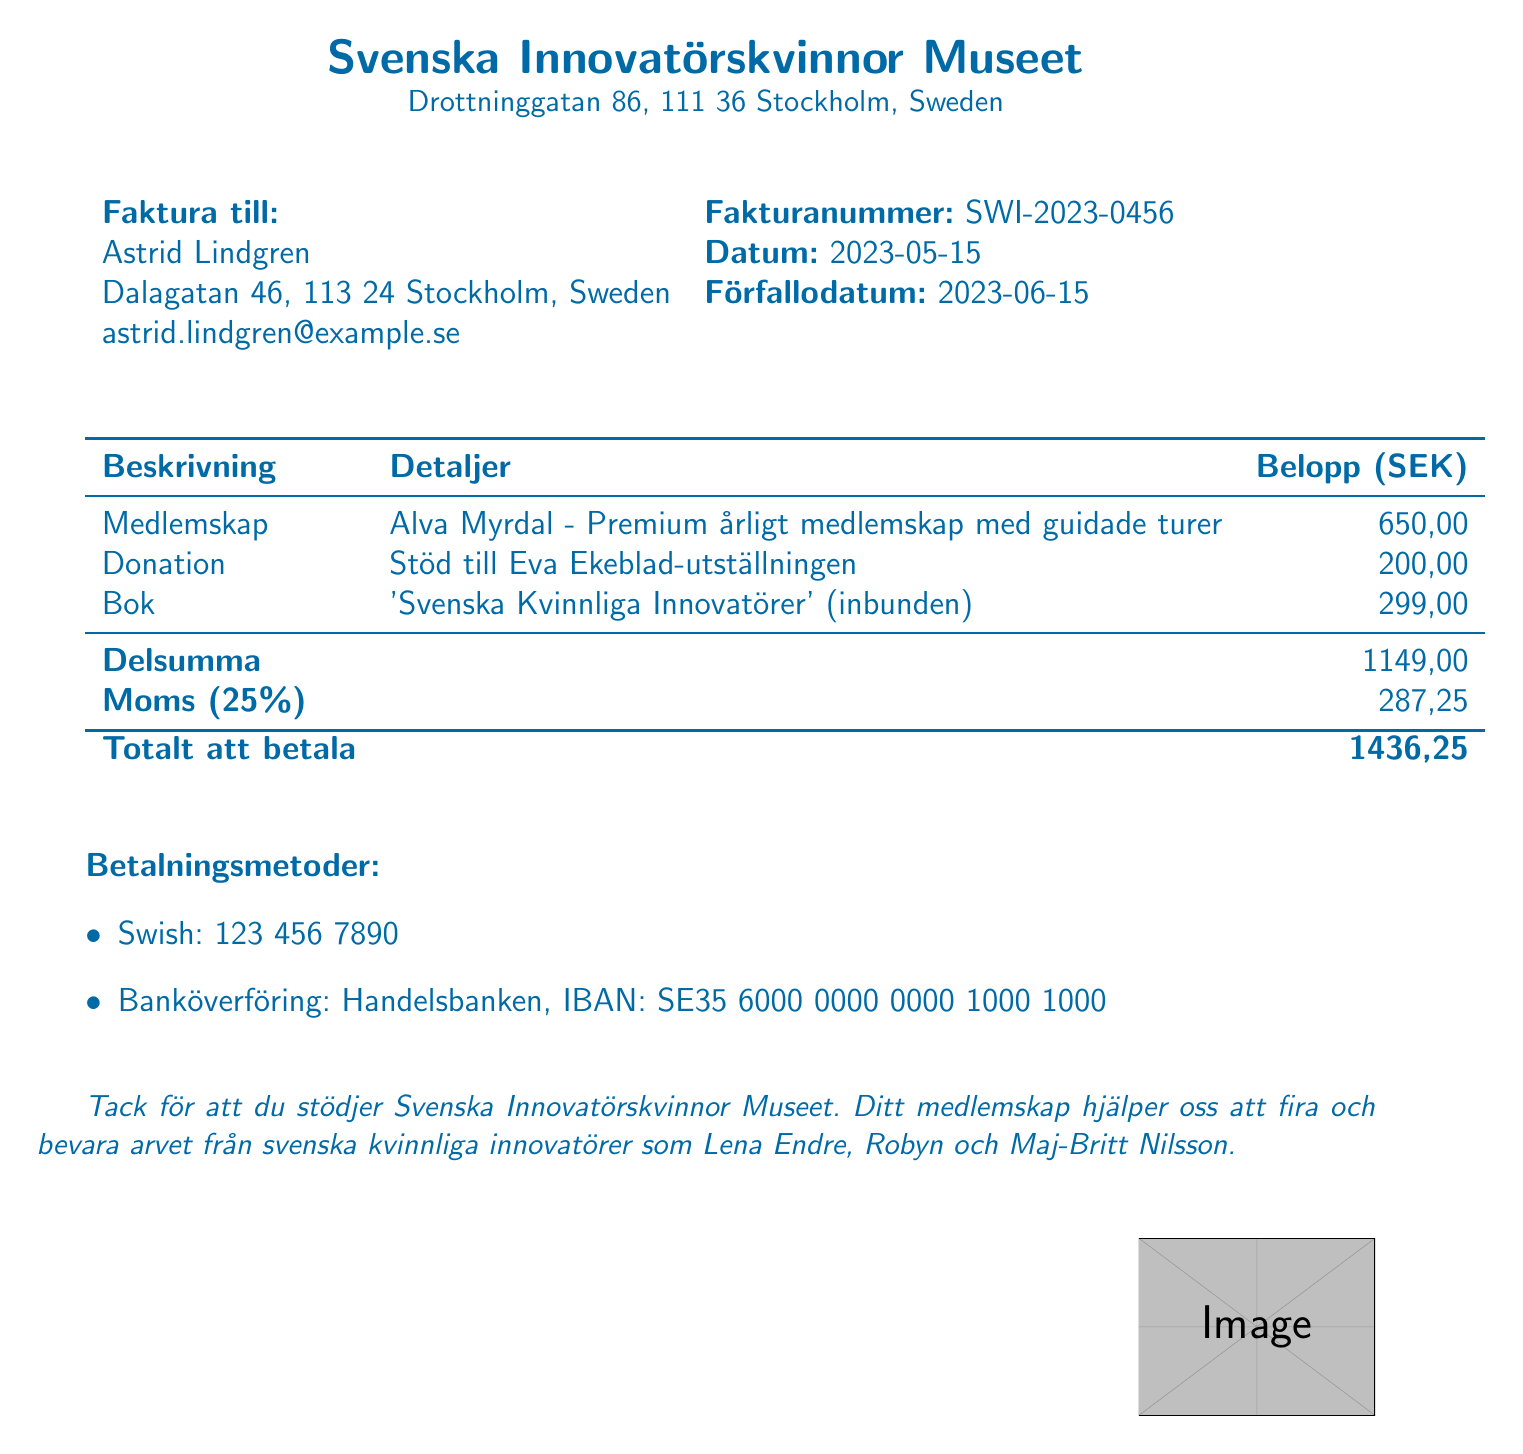what is the invoice number? The invoice number is a unique identifier for the billing document, specified in the invoice details section.
Answer: SWI-2023-0456 what is the due date for the invoice? The due date indicates the deadline for payment, found in the invoice details section.
Answer: 2023-06-15 who is the customer? The customer refers to the individual or entity being billed, as listed in the customer information section.
Answer: Astrid Lindgren what is the price of the selected membership tier? The price of the selected membership tier is stated in the membership tiers section of the document.
Answer: 650 SEK what is the total amount due? The total amount due is the sum of all charges and taxes in the invoice, found at the bottom of the document.
Answer: 1436.25 SEK what type of membership is selected? The selected membership type describes the benefits, found in both the membership tiers and selected tier sections.
Answer: Alva Myrdal how much is donated to the Eva Ekeblad Exhibition? The donation is specified under additional items, detailing support for a particular exhibition.
Answer: 200 SEK what percentage is the tax applied? The tax percentage is indicated in the invoice, reflecting the tax applied to the subtotal.
Answer: 25% which payment method is mentioned first? The first payment method mentioned gives options for settling the invoice and is generally listed in order of preference.
Answer: Swish 